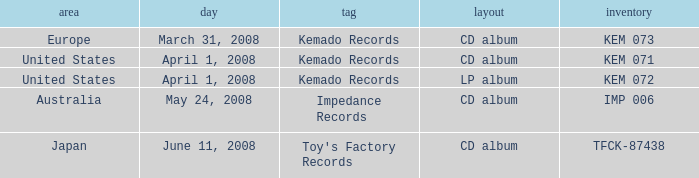Could you parse the entire table as a dict? {'header': ['area', 'day', 'tag', 'layout', 'inventory'], 'rows': [['Europe', 'March 31, 2008', 'Kemado Records', 'CD album', 'KEM 073'], ['United States', 'April 1, 2008', 'Kemado Records', 'CD album', 'KEM 071'], ['United States', 'April 1, 2008', 'Kemado Records', 'LP album', 'KEM 072'], ['Australia', 'May 24, 2008', 'Impedance Records', 'CD album', 'IMP 006'], ['Japan', 'June 11, 2008', "Toy's Factory Records", 'CD album', 'TFCK-87438']]} Which Region has a Format of cd album, and a Label of kemado records, and a Catalog of kem 071? United States. 